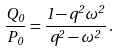<formula> <loc_0><loc_0><loc_500><loc_500>\frac { Q _ { 0 } } { P _ { 0 } } = \frac { 1 - q ^ { 2 } \omega ^ { 2 } } { q ^ { 2 } - \omega ^ { 2 } } \, .</formula> 